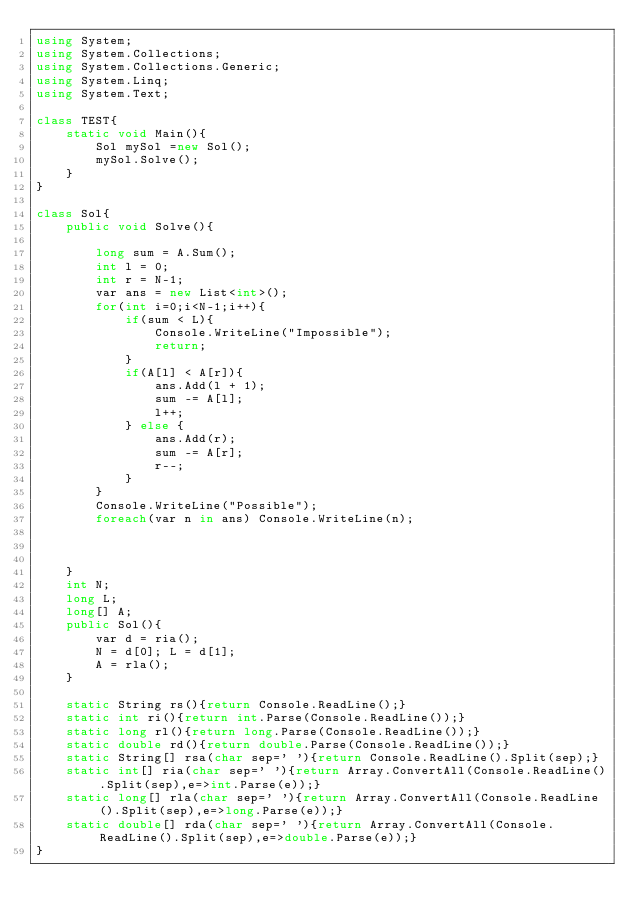<code> <loc_0><loc_0><loc_500><loc_500><_C#_>using System;
using System.Collections;
using System.Collections.Generic;
using System.Linq;
using System.Text;

class TEST{
	static void Main(){
		Sol mySol =new Sol();
		mySol.Solve();
	}
}

class Sol{
	public void Solve(){
		
		long sum = A.Sum();
		int l = 0;
		int r = N-1;
		var ans = new List<int>();
		for(int i=0;i<N-1;i++){
			if(sum < L){
				Console.WriteLine("Impossible");
				return;
			}
			if(A[l] < A[r]){
				ans.Add(l + 1);
				sum -= A[l];
				l++;
			} else {
				ans.Add(r);
				sum -= A[r];
				r--;
			}
		}
		Console.WriteLine("Possible");
		foreach(var n in ans) Console.WriteLine(n);
		
		
		
	}
	int N;
	long L;
	long[] A;
	public Sol(){
		var d = ria();
		N = d[0]; L = d[1];
		A = rla();
	}

	static String rs(){return Console.ReadLine();}
	static int ri(){return int.Parse(Console.ReadLine());}
	static long rl(){return long.Parse(Console.ReadLine());}
	static double rd(){return double.Parse(Console.ReadLine());}
	static String[] rsa(char sep=' '){return Console.ReadLine().Split(sep);}
	static int[] ria(char sep=' '){return Array.ConvertAll(Console.ReadLine().Split(sep),e=>int.Parse(e));}
	static long[] rla(char sep=' '){return Array.ConvertAll(Console.ReadLine().Split(sep),e=>long.Parse(e));}
	static double[] rda(char sep=' '){return Array.ConvertAll(Console.ReadLine().Split(sep),e=>double.Parse(e));}
}
</code> 